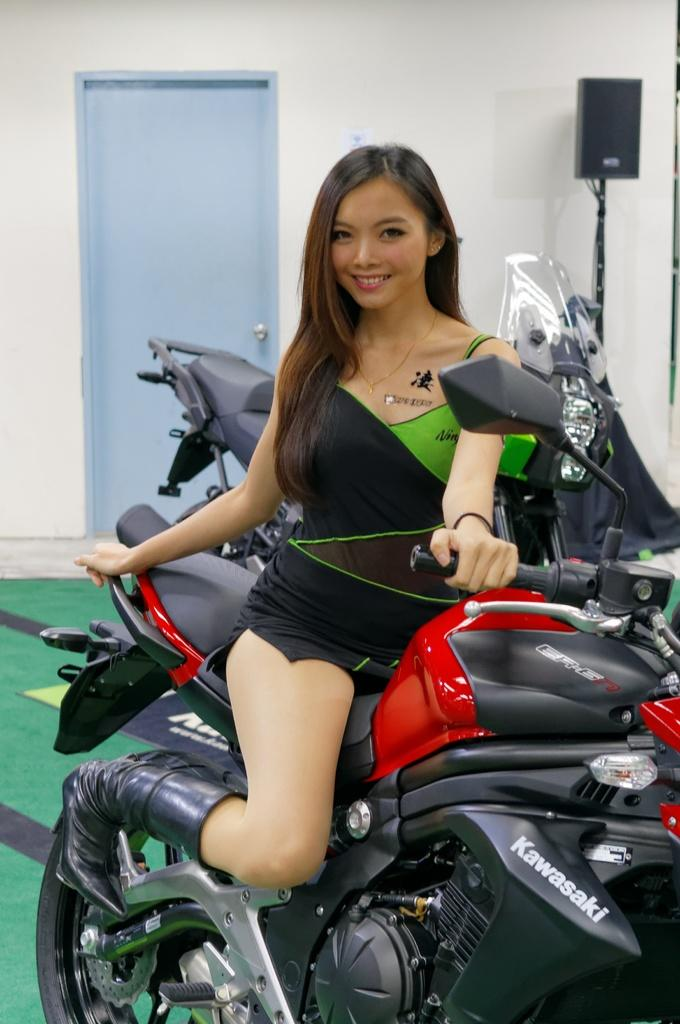What is the woman in the image doing? The woman is sitting on a motorbike in the image. Can you describe the background of the image? There is another motorbike, a door, and a wall with a speaker in the background of the image. Where is the faucet located in the image? There is no faucet present in the image. What type of structure is the woman helping to build in the image? The image does not show the woman helping to build any structure. 